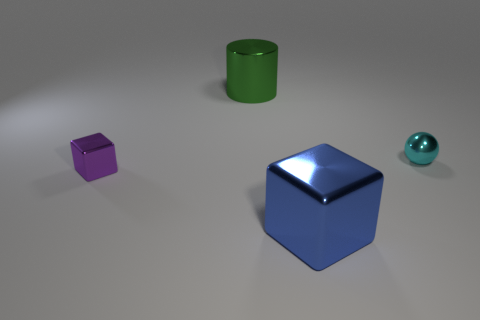There is a large thing that is on the right side of the large object behind the blue metallic block; what shape is it?
Keep it short and to the point. Cube. There is a big object that is behind the purple object; does it have the same color as the large shiny cube?
Give a very brief answer. No. What color is the metallic object that is to the left of the small cyan shiny thing and to the right of the large green thing?
Offer a very short reply. Blue. Is there a cylinder that has the same material as the green thing?
Provide a short and direct response. No. What size is the metallic sphere?
Offer a terse response. Small. There is a cube that is on the right side of the shiny object to the left of the metallic cylinder; what size is it?
Make the answer very short. Large. What is the material of the tiny purple thing that is the same shape as the blue shiny object?
Provide a short and direct response. Metal. How many big metal cylinders are there?
Ensure brevity in your answer.  1. There is a metallic cube that is on the right side of the cube to the left of the shiny object in front of the small purple metallic thing; what is its color?
Offer a very short reply. Blue. Is the number of yellow matte cylinders less than the number of cylinders?
Your response must be concise. Yes. 